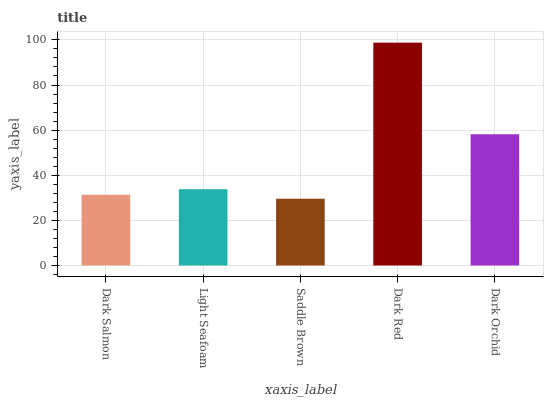Is Light Seafoam the minimum?
Answer yes or no. No. Is Light Seafoam the maximum?
Answer yes or no. No. Is Light Seafoam greater than Dark Salmon?
Answer yes or no. Yes. Is Dark Salmon less than Light Seafoam?
Answer yes or no. Yes. Is Dark Salmon greater than Light Seafoam?
Answer yes or no. No. Is Light Seafoam less than Dark Salmon?
Answer yes or no. No. Is Light Seafoam the high median?
Answer yes or no. Yes. Is Light Seafoam the low median?
Answer yes or no. Yes. Is Dark Orchid the high median?
Answer yes or no. No. Is Dark Orchid the low median?
Answer yes or no. No. 